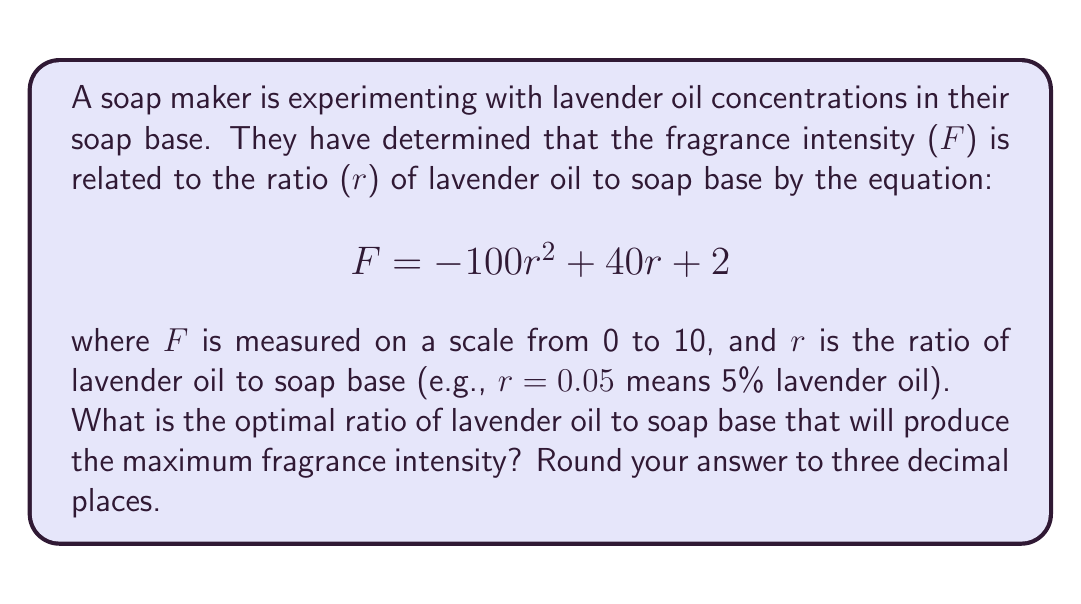What is the answer to this math problem? To find the optimal ratio that produces the maximum fragrance intensity, we need to find the maximum point of the quadratic function given by the equation:

$$ F = -100r^2 + 40r + 2 $$

For a quadratic function in the form $f(x) = ax^2 + bx + c$, the x-coordinate of the vertex (which gives the maximum or minimum point) is given by the formula:

$$ x = -\frac{b}{2a} $$

In our case:
$a = -100$
$b = 40$
$c = 2$

Substituting these values into the formula:

$$ r = -\frac{40}{2(-100)} = -\frac{40}{-200} = \frac{40}{200} = 0.2 $$

To verify this is a maximum (not a minimum), we can check that $a < 0$, which it is in this case.

Therefore, the optimal ratio of lavender oil to soap base is 0.2, or 20%.

Rounding to three decimal places as requested in the question, we get 0.200.
Answer: 0.200 